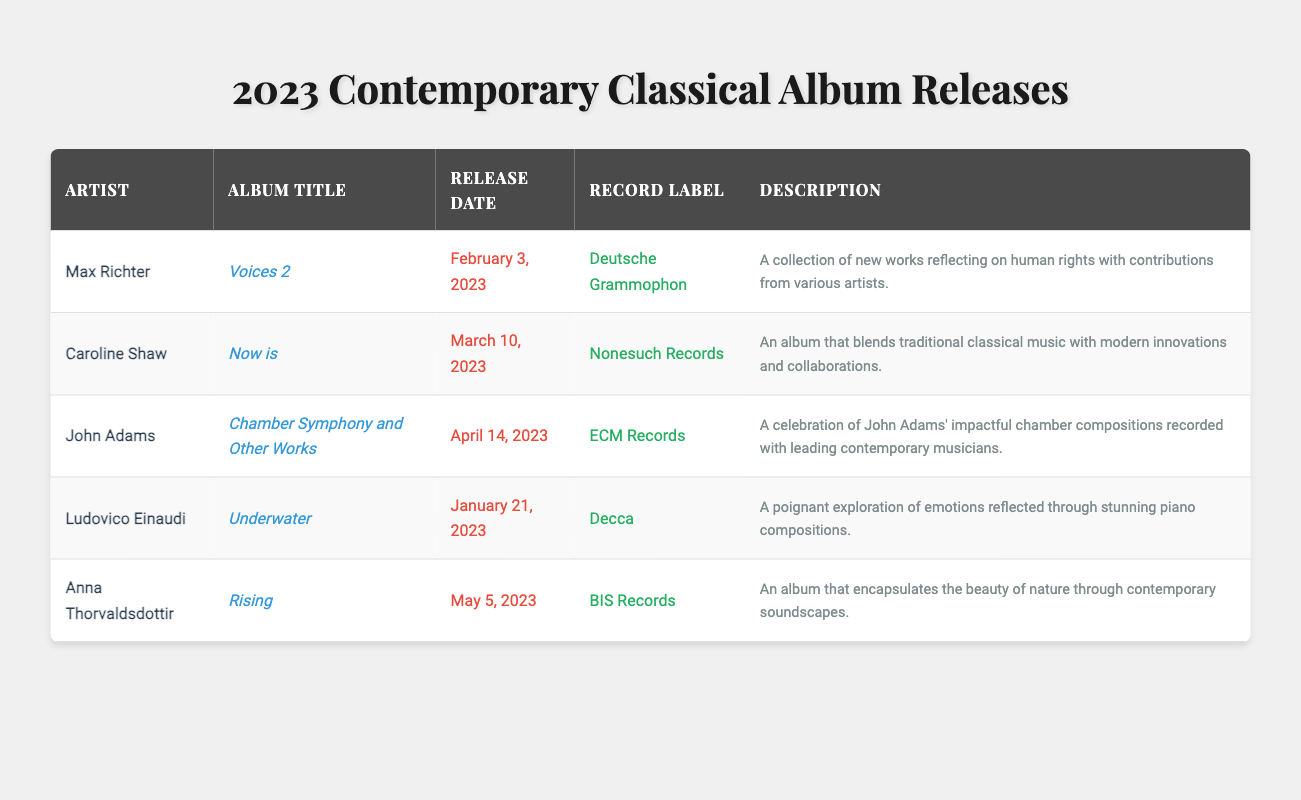What is the title of the album by Max Richter released in 2023? Max Richter's album released in 2023 is titled "Voices 2." This information is directly found in the row corresponding to Max Richter in the table.
Answer: Voices 2 Which artist released an album on March 10, 2023? According to the table, Caroline Shaw released her album titled "Now is" on March 10, 2023. The specific release date is mentioned in the corresponding row for Caroline Shaw.
Answer: Caroline Shaw Is "Rising" the title of an album by Anna Thorvaldsdottir? Yes, the table indicates that "Rising" is indeed the title of an album released by Anna Thorvaldsdottir on May 5, 2023, confirming the fact stated in the question.
Answer: Yes What is the record label for John Adams' album? John Adams' album "Chamber Symphony and Other Works" is released under the record label ECM Records, as shown in the relevant row of the table.
Answer: ECM Records Which album released in January 2023 has a piano focus? The album titled "Underwater" by Ludovico Einaudi, released on January 21, 2023, focuses on piano compositions, as specified in the description within the table.
Answer: Underwater Which artist has an album with a description related to human rights? The table states that Max Richter’s album "Voices 2" reflects on human rights, indicating that he is the artist associated with this theme in his album.
Answer: Max Richter How many albums were released between February and April 2023? From the table, we see that there are three albums released within that timeframe: "Voices 2" (February 3), "Now is" (March 10), and "Chamber Symphony and Other Works" (April 14). Adding these gives us a total of three albums.
Answer: 3 Did Ludovico Einaudi release an album before March 2023? Yes, Ludovico Einaudi's album "Underwater" was released on January 21, 2023, which is before March 2023. This is verified by looking at the release date in the table.
Answer: Yes What is the album title with the earliest release date among the listed entries? The earliest release date is for Ludovico Einaudi's album "Underwater," which was released on January 21, 2023. This can be verified by reviewing the release dates in the table.
Answer: Underwater 